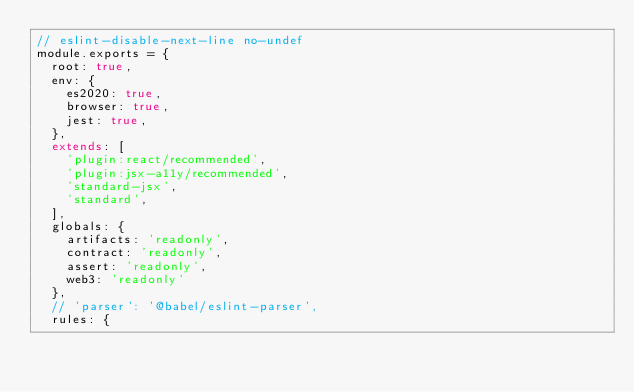<code> <loc_0><loc_0><loc_500><loc_500><_JavaScript_>// eslint-disable-next-line no-undef
module.exports = {
  root: true,
  env: {
    es2020: true,
    browser: true,
    jest: true,
  },
  extends: [
    'plugin:react/recommended',
    'plugin:jsx-a11y/recommended',
    'standard-jsx',
    'standard',
  ],
  globals: {
    artifacts: 'readonly',
    contract: 'readonly',
    assert: 'readonly',
    web3: 'readonly'
  },
  // 'parser': '@babel/eslint-parser',
  rules: {</code> 